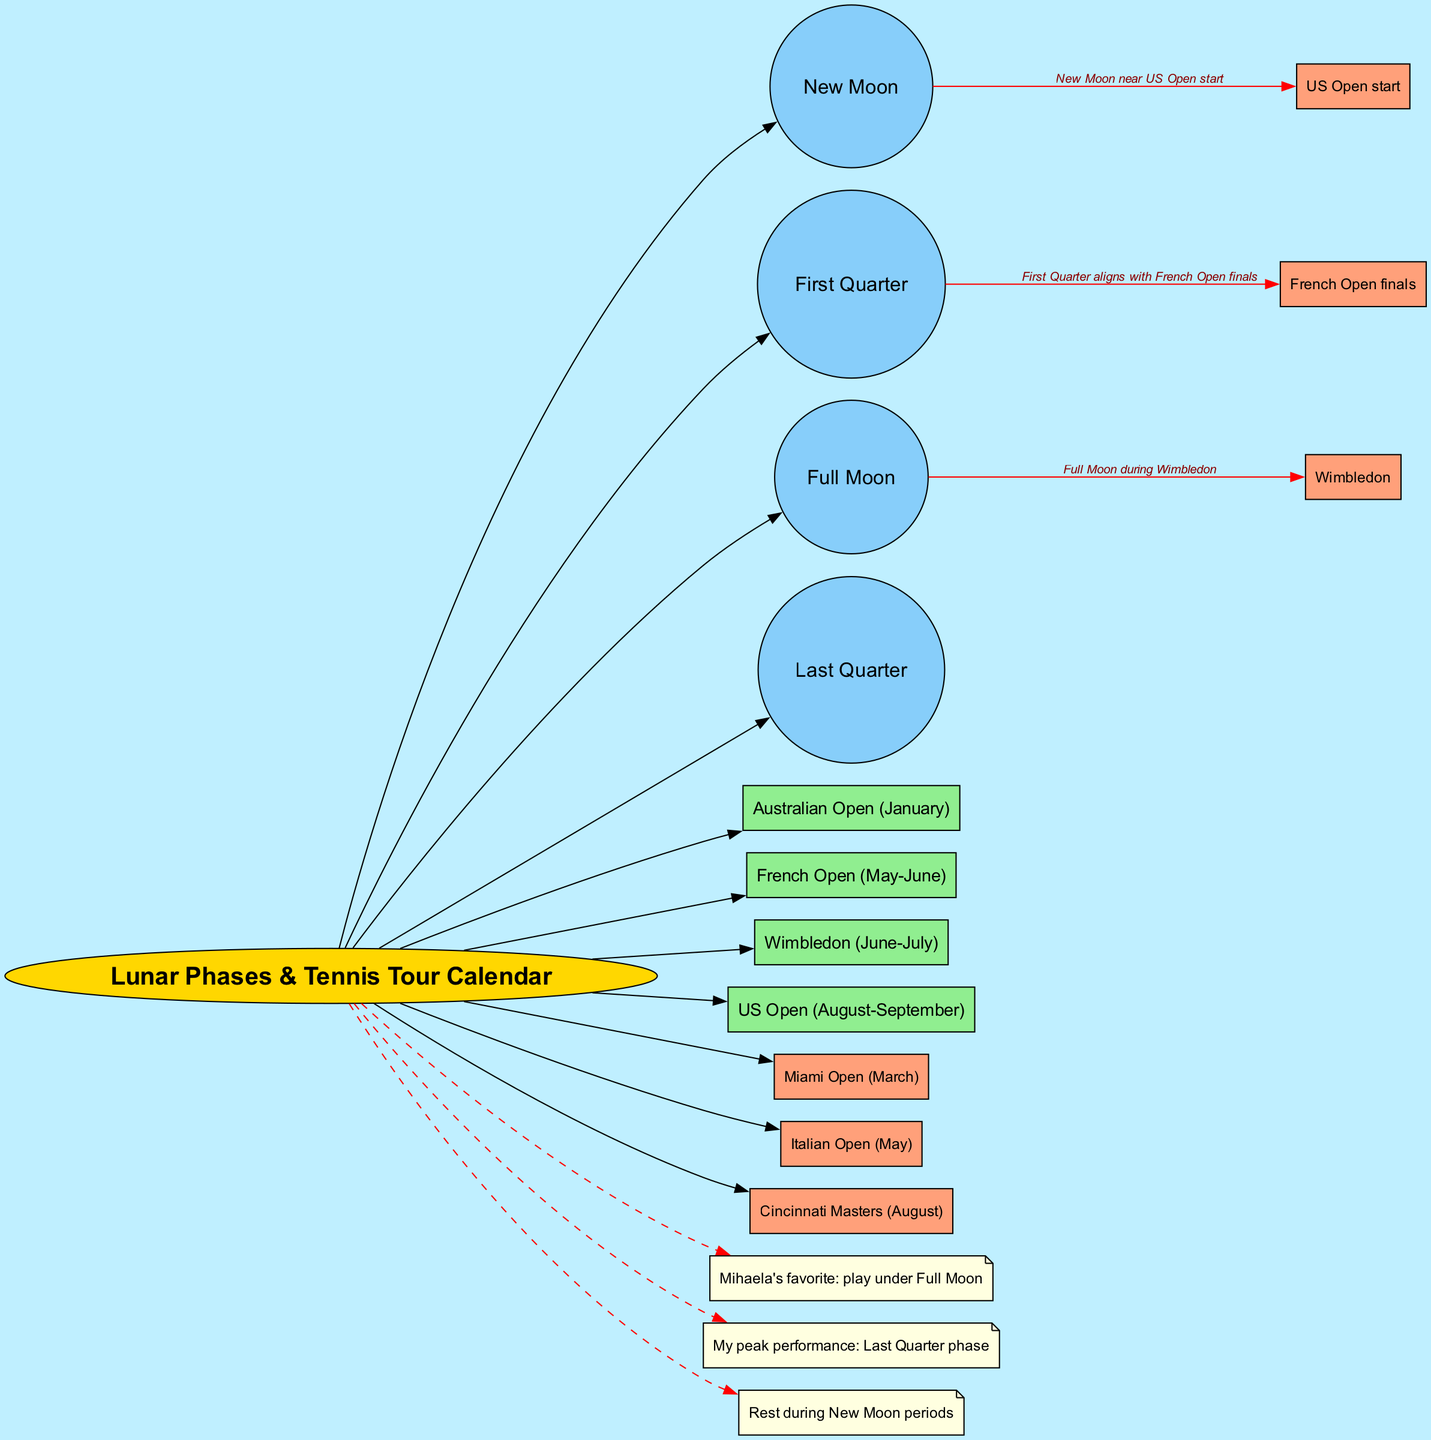What are the four lunar phases represented in the diagram? The four lunar phases listed in the diagram are New Moon, First Quarter, Full Moon, and Last Quarter. They can be directly observed as discrete nodes stemming from the central element.
Answer: New Moon, First Quarter, Full Moon, Last Quarter Which tournament is aligned with the Full Moon phase? In the connections section, it states that the Full Moon occurs during Wimbledon, which directly indicates the relationship between the lunar phase and the tournament.
Answer: Wimbledon How many Grand Slam tournaments are mentioned in the diagram? By counting the rectangles connected to the central element labeled as Grand Slams, three distinct tournaments are identified: Australian Open, French Open, and US Open.
Answer: Four What personal note indicates a preferred playing condition for Mihaela Buzărnescu? Among the personal notes, it explicitly mentions Mihaela's favorite condition for playing under a Full Moon, thus highlighting her preference for lunar phases in competitive scenarios.
Answer: play under Full Moon During which lunar phase does the individual mentioned in the notes achieve peak performance? The notes clearly state that the individual's peak performance phase is during the Last Quarter, as indicated by the personal notes section of the diagram.
Answer: Last Quarter What month does the New Moon align with in relation to the US Open? The connection described in the diagram indicates that the New Moon occurs near the start of the US Open, establishing a direct temporal relationship.
Answer: near US Open start How are the key tournaments represented in the diagram? The key tournaments are represented by rectangular nodes, specifically labeled Miami Open, Italian Open, and Cincinnati Masters, which connect directly to the central element.
Answer: Miami Open, Italian Open, Cincinnati Masters Which lunar phase aligns with the French Open finals? According to the connections found in the diagram, the First Quarter aligns with the French Open finals, indicating their respective timing in relation to each other.
Answer: First Quarter What is the color used for nodes representing Grand Slam tournaments? The Grand Slam tournament nodes are distinctly colored light green, which is specified in the diagram's attributes for those nodes.
Answer: light green 